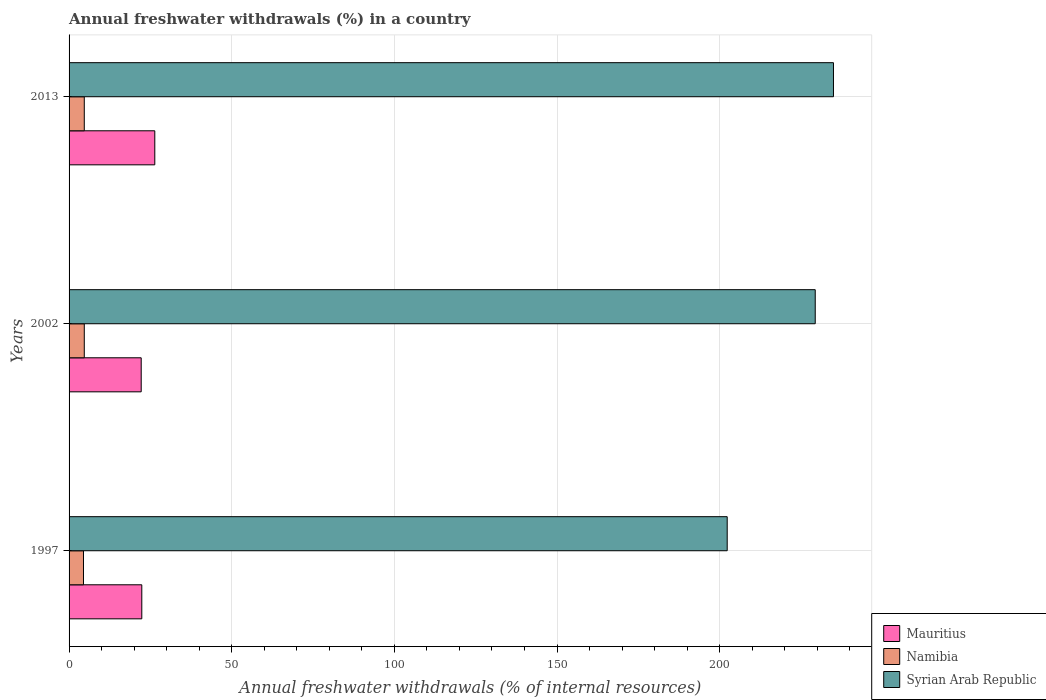How many different coloured bars are there?
Your answer should be compact. 3. Are the number of bars per tick equal to the number of legend labels?
Offer a very short reply. Yes. Are the number of bars on each tick of the Y-axis equal?
Provide a short and direct response. Yes. How many bars are there on the 1st tick from the top?
Keep it short and to the point. 3. How many bars are there on the 1st tick from the bottom?
Provide a succinct answer. 3. What is the percentage of annual freshwater withdrawals in Mauritius in 1997?
Offer a terse response. 22.36. Across all years, what is the maximum percentage of annual freshwater withdrawals in Mauritius?
Provide a succinct answer. 26.35. Across all years, what is the minimum percentage of annual freshwater withdrawals in Mauritius?
Your answer should be very brief. 22.17. In which year was the percentage of annual freshwater withdrawals in Syrian Arab Republic maximum?
Offer a very short reply. 2013. In which year was the percentage of annual freshwater withdrawals in Syrian Arab Republic minimum?
Provide a succinct answer. 1997. What is the total percentage of annual freshwater withdrawals in Syrian Arab Republic in the graph?
Give a very brief answer. 666.71. What is the difference between the percentage of annual freshwater withdrawals in Mauritius in 2002 and that in 2013?
Offer a very short reply. -4.18. What is the difference between the percentage of annual freshwater withdrawals in Mauritius in 1997 and the percentage of annual freshwater withdrawals in Namibia in 2002?
Ensure brevity in your answer.  17.68. What is the average percentage of annual freshwater withdrawals in Syrian Arab Republic per year?
Your response must be concise. 222.24. In the year 2013, what is the difference between the percentage of annual freshwater withdrawals in Namibia and percentage of annual freshwater withdrawals in Mauritius?
Offer a very short reply. -21.68. What is the ratio of the percentage of annual freshwater withdrawals in Namibia in 2002 to that in 2013?
Your answer should be compact. 1. Is the percentage of annual freshwater withdrawals in Namibia in 1997 less than that in 2013?
Offer a terse response. Yes. What is the difference between the highest and the second highest percentage of annual freshwater withdrawals in Mauritius?
Keep it short and to the point. 4. What is the difference between the highest and the lowest percentage of annual freshwater withdrawals in Mauritius?
Keep it short and to the point. 4.18. What does the 1st bar from the top in 2002 represents?
Provide a short and direct response. Syrian Arab Republic. What does the 3rd bar from the bottom in 2013 represents?
Offer a terse response. Syrian Arab Republic. Is it the case that in every year, the sum of the percentage of annual freshwater withdrawals in Namibia and percentage of annual freshwater withdrawals in Syrian Arab Republic is greater than the percentage of annual freshwater withdrawals in Mauritius?
Provide a short and direct response. Yes. Are all the bars in the graph horizontal?
Make the answer very short. Yes. Does the graph contain any zero values?
Your response must be concise. No. What is the title of the graph?
Give a very brief answer. Annual freshwater withdrawals (%) in a country. Does "Cabo Verde" appear as one of the legend labels in the graph?
Ensure brevity in your answer.  No. What is the label or title of the X-axis?
Provide a succinct answer. Annual freshwater withdrawals (% of internal resources). What is the label or title of the Y-axis?
Keep it short and to the point. Years. What is the Annual freshwater withdrawals (% of internal resources) in Mauritius in 1997?
Your answer should be very brief. 22.36. What is the Annual freshwater withdrawals (% of internal resources) in Namibia in 1997?
Offer a terse response. 4.43. What is the Annual freshwater withdrawals (% of internal resources) of Syrian Arab Republic in 1997?
Your response must be concise. 202.33. What is the Annual freshwater withdrawals (% of internal resources) of Mauritius in 2002?
Offer a very short reply. 22.17. What is the Annual freshwater withdrawals (% of internal resources) in Namibia in 2002?
Your answer should be very brief. 4.68. What is the Annual freshwater withdrawals (% of internal resources) in Syrian Arab Republic in 2002?
Ensure brevity in your answer.  229.39. What is the Annual freshwater withdrawals (% of internal resources) in Mauritius in 2013?
Provide a short and direct response. 26.35. What is the Annual freshwater withdrawals (% of internal resources) in Namibia in 2013?
Your answer should be very brief. 4.68. What is the Annual freshwater withdrawals (% of internal resources) of Syrian Arab Republic in 2013?
Ensure brevity in your answer.  235. Across all years, what is the maximum Annual freshwater withdrawals (% of internal resources) of Mauritius?
Offer a very short reply. 26.35. Across all years, what is the maximum Annual freshwater withdrawals (% of internal resources) of Namibia?
Offer a very short reply. 4.68. Across all years, what is the maximum Annual freshwater withdrawals (% of internal resources) of Syrian Arab Republic?
Provide a succinct answer. 235. Across all years, what is the minimum Annual freshwater withdrawals (% of internal resources) in Mauritius?
Provide a short and direct response. 22.17. Across all years, what is the minimum Annual freshwater withdrawals (% of internal resources) of Namibia?
Offer a terse response. 4.43. Across all years, what is the minimum Annual freshwater withdrawals (% of internal resources) of Syrian Arab Republic?
Make the answer very short. 202.33. What is the total Annual freshwater withdrawals (% of internal resources) of Mauritius in the graph?
Offer a terse response. 70.88. What is the total Annual freshwater withdrawals (% of internal resources) of Namibia in the graph?
Your answer should be very brief. 13.78. What is the total Annual freshwater withdrawals (% of internal resources) of Syrian Arab Republic in the graph?
Provide a succinct answer. 666.71. What is the difference between the Annual freshwater withdrawals (% of internal resources) of Mauritius in 1997 and that in 2002?
Give a very brief answer. 0.18. What is the difference between the Annual freshwater withdrawals (% of internal resources) of Namibia in 1997 and that in 2002?
Provide a succinct answer. -0.24. What is the difference between the Annual freshwater withdrawals (% of internal resources) in Syrian Arab Republic in 1997 and that in 2002?
Your response must be concise. -27.06. What is the difference between the Annual freshwater withdrawals (% of internal resources) of Mauritius in 1997 and that in 2013?
Offer a very short reply. -4. What is the difference between the Annual freshwater withdrawals (% of internal resources) in Namibia in 1997 and that in 2013?
Your answer should be compact. -0.24. What is the difference between the Annual freshwater withdrawals (% of internal resources) of Syrian Arab Republic in 1997 and that in 2013?
Provide a succinct answer. -32.67. What is the difference between the Annual freshwater withdrawals (% of internal resources) in Mauritius in 2002 and that in 2013?
Your answer should be very brief. -4.18. What is the difference between the Annual freshwater withdrawals (% of internal resources) of Namibia in 2002 and that in 2013?
Offer a very short reply. 0. What is the difference between the Annual freshwater withdrawals (% of internal resources) of Syrian Arab Republic in 2002 and that in 2013?
Make the answer very short. -5.61. What is the difference between the Annual freshwater withdrawals (% of internal resources) in Mauritius in 1997 and the Annual freshwater withdrawals (% of internal resources) in Namibia in 2002?
Make the answer very short. 17.68. What is the difference between the Annual freshwater withdrawals (% of internal resources) of Mauritius in 1997 and the Annual freshwater withdrawals (% of internal resources) of Syrian Arab Republic in 2002?
Your response must be concise. -207.03. What is the difference between the Annual freshwater withdrawals (% of internal resources) of Namibia in 1997 and the Annual freshwater withdrawals (% of internal resources) of Syrian Arab Republic in 2002?
Provide a succinct answer. -224.96. What is the difference between the Annual freshwater withdrawals (% of internal resources) of Mauritius in 1997 and the Annual freshwater withdrawals (% of internal resources) of Namibia in 2013?
Your response must be concise. 17.68. What is the difference between the Annual freshwater withdrawals (% of internal resources) in Mauritius in 1997 and the Annual freshwater withdrawals (% of internal resources) in Syrian Arab Republic in 2013?
Your answer should be compact. -212.64. What is the difference between the Annual freshwater withdrawals (% of internal resources) in Namibia in 1997 and the Annual freshwater withdrawals (% of internal resources) in Syrian Arab Republic in 2013?
Your response must be concise. -230.57. What is the difference between the Annual freshwater withdrawals (% of internal resources) of Mauritius in 2002 and the Annual freshwater withdrawals (% of internal resources) of Namibia in 2013?
Your answer should be very brief. 17.5. What is the difference between the Annual freshwater withdrawals (% of internal resources) in Mauritius in 2002 and the Annual freshwater withdrawals (% of internal resources) in Syrian Arab Republic in 2013?
Your answer should be compact. -212.82. What is the difference between the Annual freshwater withdrawals (% of internal resources) of Namibia in 2002 and the Annual freshwater withdrawals (% of internal resources) of Syrian Arab Republic in 2013?
Offer a very short reply. -230.32. What is the average Annual freshwater withdrawals (% of internal resources) of Mauritius per year?
Your response must be concise. 23.63. What is the average Annual freshwater withdrawals (% of internal resources) in Namibia per year?
Offer a terse response. 4.59. What is the average Annual freshwater withdrawals (% of internal resources) of Syrian Arab Republic per year?
Keep it short and to the point. 222.24. In the year 1997, what is the difference between the Annual freshwater withdrawals (% of internal resources) of Mauritius and Annual freshwater withdrawals (% of internal resources) of Namibia?
Give a very brief answer. 17.92. In the year 1997, what is the difference between the Annual freshwater withdrawals (% of internal resources) in Mauritius and Annual freshwater withdrawals (% of internal resources) in Syrian Arab Republic?
Your answer should be compact. -179.97. In the year 1997, what is the difference between the Annual freshwater withdrawals (% of internal resources) of Namibia and Annual freshwater withdrawals (% of internal resources) of Syrian Arab Republic?
Provide a succinct answer. -197.9. In the year 2002, what is the difference between the Annual freshwater withdrawals (% of internal resources) in Mauritius and Annual freshwater withdrawals (% of internal resources) in Namibia?
Make the answer very short. 17.5. In the year 2002, what is the difference between the Annual freshwater withdrawals (% of internal resources) in Mauritius and Annual freshwater withdrawals (% of internal resources) in Syrian Arab Republic?
Provide a succinct answer. -207.21. In the year 2002, what is the difference between the Annual freshwater withdrawals (% of internal resources) in Namibia and Annual freshwater withdrawals (% of internal resources) in Syrian Arab Republic?
Make the answer very short. -224.71. In the year 2013, what is the difference between the Annual freshwater withdrawals (% of internal resources) of Mauritius and Annual freshwater withdrawals (% of internal resources) of Namibia?
Keep it short and to the point. 21.68. In the year 2013, what is the difference between the Annual freshwater withdrawals (% of internal resources) in Mauritius and Annual freshwater withdrawals (% of internal resources) in Syrian Arab Republic?
Ensure brevity in your answer.  -208.64. In the year 2013, what is the difference between the Annual freshwater withdrawals (% of internal resources) in Namibia and Annual freshwater withdrawals (% of internal resources) in Syrian Arab Republic?
Your answer should be very brief. -230.32. What is the ratio of the Annual freshwater withdrawals (% of internal resources) in Mauritius in 1997 to that in 2002?
Your response must be concise. 1.01. What is the ratio of the Annual freshwater withdrawals (% of internal resources) of Namibia in 1997 to that in 2002?
Offer a very short reply. 0.95. What is the ratio of the Annual freshwater withdrawals (% of internal resources) of Syrian Arab Republic in 1997 to that in 2002?
Give a very brief answer. 0.88. What is the ratio of the Annual freshwater withdrawals (% of internal resources) in Mauritius in 1997 to that in 2013?
Ensure brevity in your answer.  0.85. What is the ratio of the Annual freshwater withdrawals (% of internal resources) in Namibia in 1997 to that in 2013?
Your answer should be compact. 0.95. What is the ratio of the Annual freshwater withdrawals (% of internal resources) of Syrian Arab Republic in 1997 to that in 2013?
Your response must be concise. 0.86. What is the ratio of the Annual freshwater withdrawals (% of internal resources) in Mauritius in 2002 to that in 2013?
Your answer should be very brief. 0.84. What is the ratio of the Annual freshwater withdrawals (% of internal resources) of Syrian Arab Republic in 2002 to that in 2013?
Offer a terse response. 0.98. What is the difference between the highest and the second highest Annual freshwater withdrawals (% of internal resources) of Mauritius?
Offer a terse response. 4. What is the difference between the highest and the second highest Annual freshwater withdrawals (% of internal resources) in Namibia?
Give a very brief answer. 0. What is the difference between the highest and the second highest Annual freshwater withdrawals (% of internal resources) of Syrian Arab Republic?
Keep it short and to the point. 5.61. What is the difference between the highest and the lowest Annual freshwater withdrawals (% of internal resources) of Mauritius?
Keep it short and to the point. 4.18. What is the difference between the highest and the lowest Annual freshwater withdrawals (% of internal resources) in Namibia?
Make the answer very short. 0.24. What is the difference between the highest and the lowest Annual freshwater withdrawals (% of internal resources) of Syrian Arab Republic?
Your answer should be very brief. 32.67. 